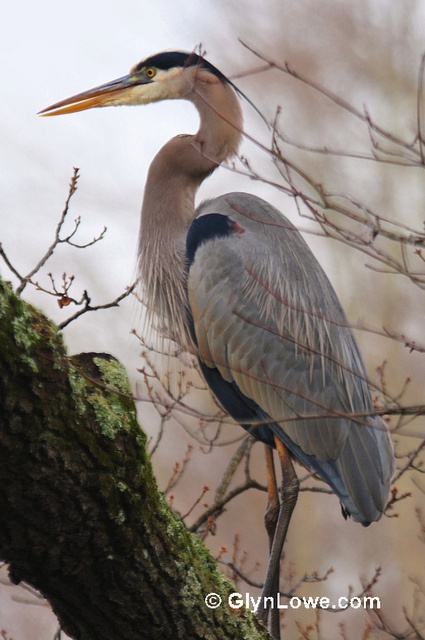Describe the objects in this image and their specific colors. I can see a bird in white, gray, and black tones in this image. 